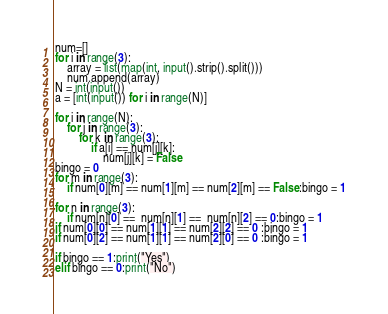Convert code to text. <code><loc_0><loc_0><loc_500><loc_500><_Python_>num=[]
for i in range(3):
    array = list(map(int, input().strip().split()))
    num.append(array)
N = int(input())
a = [int(input()) for i in range(N)]

for i in range(N):
    for j in range(3):
        for k in range(3):
            if a[i] == num[j][k]:
                num[j][k] = False
bingo = 0
for m in range(3):
    if num[0][m] == num[1][m] == num[2][m] == False:bingo = 1

for n in range(3):
    if num[n][0] ==  num[n][1] ==  num[n][2] == 0:bingo = 1 
if num[0][0] == num[1][1] == num[2][2] == 0 :bingo = 1
if num[0][2] == num[1][1] == num[2][0] == 0 :bingo = 1

if bingo == 1:print("Yes")
elif bingo == 0:print("No")


</code> 